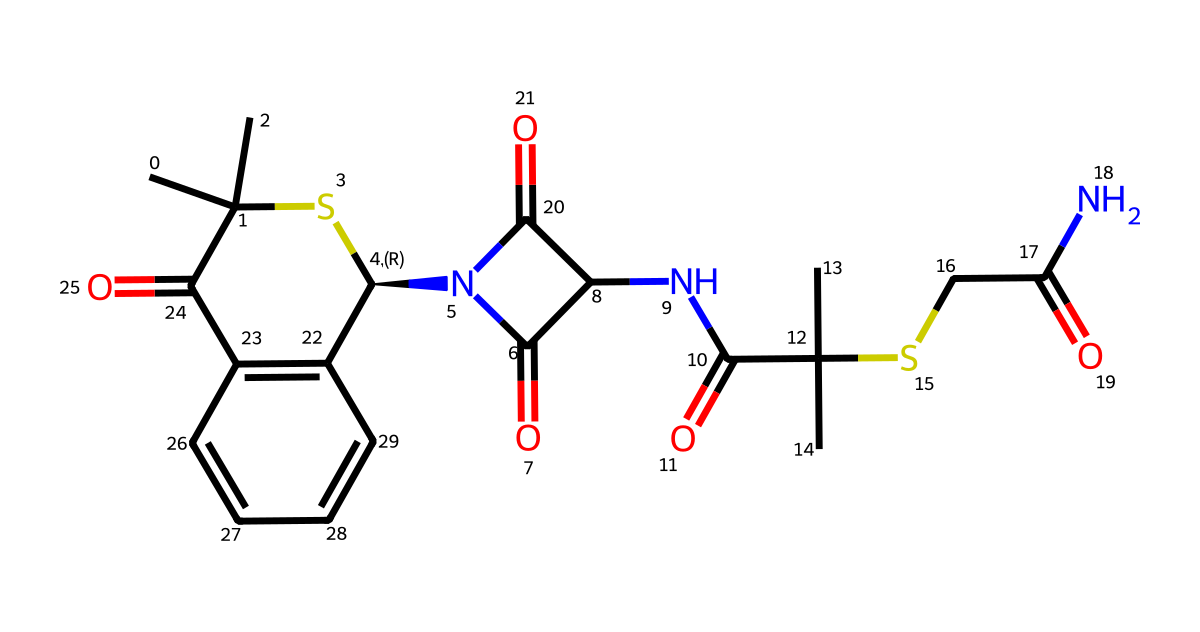What type of drug is represented by this SMILES structure? The structure represents a type of drug called a "beta-lactam antibiotic," identified by the presence of the beta-lactam ring, which is crucial for its antibacterial activity.
Answer: beta-lactam antibiotic How many chiral centers are present in this compound? Observing the structure, there are two carbon atoms with four different substituents attached, indicating the presence of two chiral centers.
Answer: 2 What is the molecular formula for this chemical? By analyzing the SMILES representation and counting the atoms, the molecular formula can be determined as C15H24N4O4S2.
Answer: C15H24N4O4S2 Which functional group is responsible for the antibiotic activity in this structure? The beta-lactam ring acts as the functional group responsible for the antibiotic activity, as it interferes with bacterial cell wall synthesis.
Answer: beta-lactam ring What is the significance of the sulfur atom in this compound? The sulfur atom is involved in the structure of the molecule and contributes to the drug's mechanism of action against bacteria, as it plays a role in binding to bacterial enzymes.
Answer: binding to bacterial enzymes How many total rings are present in this structure? There are a total of three rings visible in the chemical structure, which can be identified by examining the closed loops formed by the arrangement of atoms.
Answer: 3 